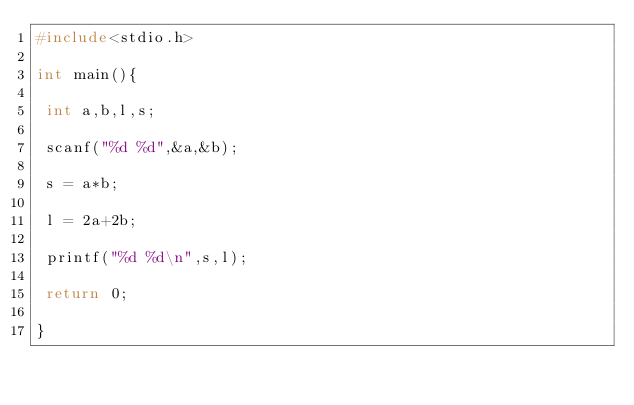Convert code to text. <code><loc_0><loc_0><loc_500><loc_500><_C_>#include<stdio.h>

int main(){

 int a,b,l,s;

 scanf("%d %d",&a,&b);

 s = a*b;

 l = 2a+2b;

 printf("%d %d\n",s,l);

 return 0;

}</code> 